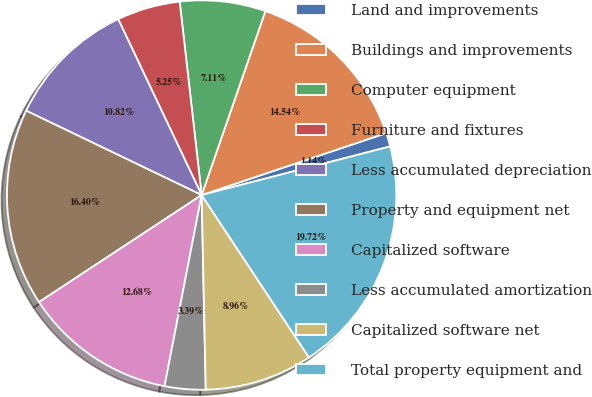Convert chart. <chart><loc_0><loc_0><loc_500><loc_500><pie_chart><fcel>Land and improvements<fcel>Buildings and improvements<fcel>Computer equipment<fcel>Furniture and fixtures<fcel>Less accumulated depreciation<fcel>Property and equipment net<fcel>Capitalized software<fcel>Less accumulated amortization<fcel>Capitalized software net<fcel>Total property equipment and<nl><fcel>1.14%<fcel>14.54%<fcel>7.11%<fcel>5.25%<fcel>10.82%<fcel>16.4%<fcel>12.68%<fcel>3.39%<fcel>8.96%<fcel>19.72%<nl></chart> 